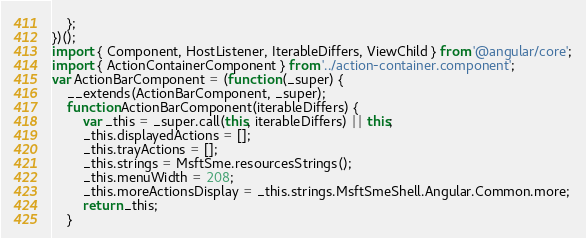<code> <loc_0><loc_0><loc_500><loc_500><_JavaScript_>    };
})();
import { Component, HostListener, IterableDiffers, ViewChild } from '@angular/core';
import { ActionContainerComponent } from '../action-container.component';
var ActionBarComponent = (function (_super) {
    __extends(ActionBarComponent, _super);
    function ActionBarComponent(iterableDiffers) {
        var _this = _super.call(this, iterableDiffers) || this;
        _this.displayedActions = [];
        _this.trayActions = [];
        _this.strings = MsftSme.resourcesStrings();
        _this.menuWidth = 208;
        _this.moreActionsDisplay = _this.strings.MsftSmeShell.Angular.Common.more;
        return _this;
    }</code> 